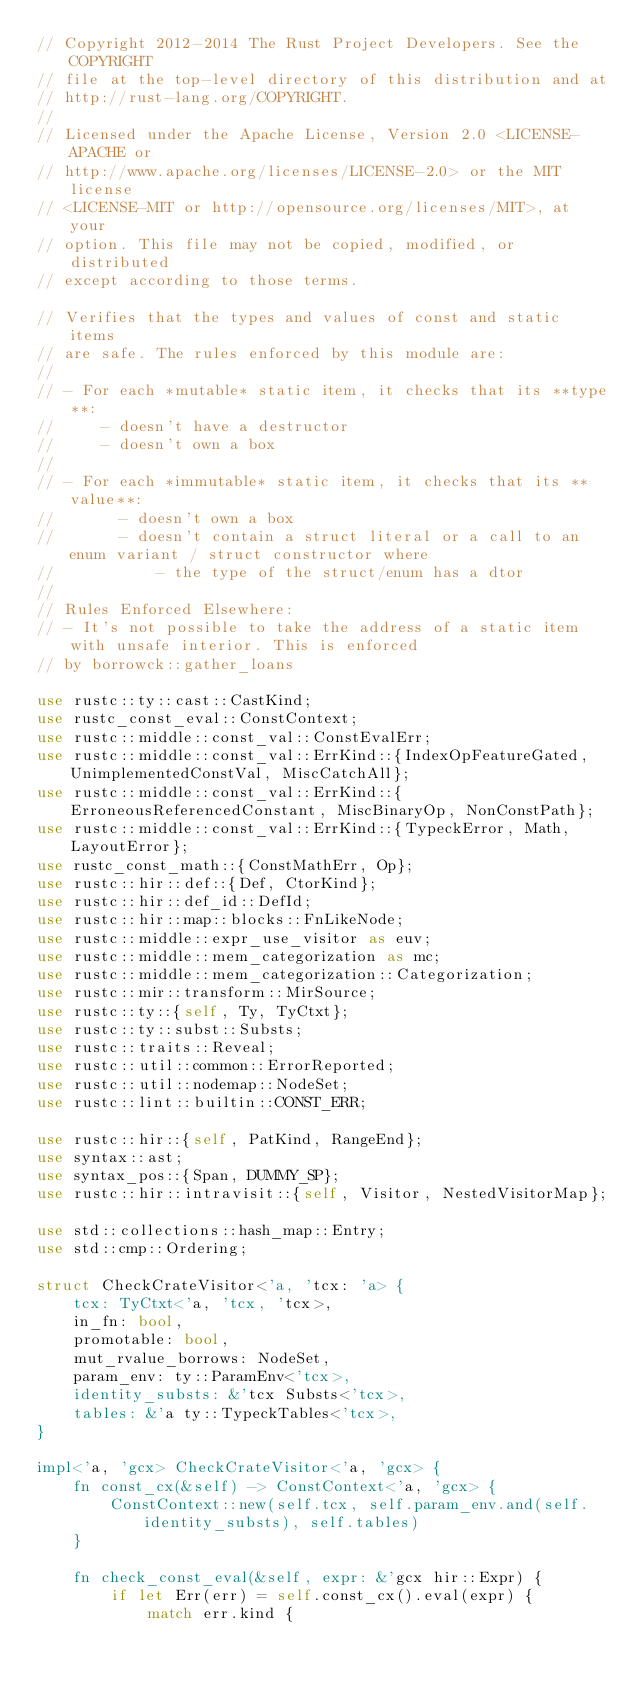Convert code to text. <code><loc_0><loc_0><loc_500><loc_500><_Rust_>// Copyright 2012-2014 The Rust Project Developers. See the COPYRIGHT
// file at the top-level directory of this distribution and at
// http://rust-lang.org/COPYRIGHT.
//
// Licensed under the Apache License, Version 2.0 <LICENSE-APACHE or
// http://www.apache.org/licenses/LICENSE-2.0> or the MIT license
// <LICENSE-MIT or http://opensource.org/licenses/MIT>, at your
// option. This file may not be copied, modified, or distributed
// except according to those terms.

// Verifies that the types and values of const and static items
// are safe. The rules enforced by this module are:
//
// - For each *mutable* static item, it checks that its **type**:
//     - doesn't have a destructor
//     - doesn't own a box
//
// - For each *immutable* static item, it checks that its **value**:
//       - doesn't own a box
//       - doesn't contain a struct literal or a call to an enum variant / struct constructor where
//           - the type of the struct/enum has a dtor
//
// Rules Enforced Elsewhere:
// - It's not possible to take the address of a static item with unsafe interior. This is enforced
// by borrowck::gather_loans

use rustc::ty::cast::CastKind;
use rustc_const_eval::ConstContext;
use rustc::middle::const_val::ConstEvalErr;
use rustc::middle::const_val::ErrKind::{IndexOpFeatureGated, UnimplementedConstVal, MiscCatchAll};
use rustc::middle::const_val::ErrKind::{ErroneousReferencedConstant, MiscBinaryOp, NonConstPath};
use rustc::middle::const_val::ErrKind::{TypeckError, Math, LayoutError};
use rustc_const_math::{ConstMathErr, Op};
use rustc::hir::def::{Def, CtorKind};
use rustc::hir::def_id::DefId;
use rustc::hir::map::blocks::FnLikeNode;
use rustc::middle::expr_use_visitor as euv;
use rustc::middle::mem_categorization as mc;
use rustc::middle::mem_categorization::Categorization;
use rustc::mir::transform::MirSource;
use rustc::ty::{self, Ty, TyCtxt};
use rustc::ty::subst::Substs;
use rustc::traits::Reveal;
use rustc::util::common::ErrorReported;
use rustc::util::nodemap::NodeSet;
use rustc::lint::builtin::CONST_ERR;

use rustc::hir::{self, PatKind, RangeEnd};
use syntax::ast;
use syntax_pos::{Span, DUMMY_SP};
use rustc::hir::intravisit::{self, Visitor, NestedVisitorMap};

use std::collections::hash_map::Entry;
use std::cmp::Ordering;

struct CheckCrateVisitor<'a, 'tcx: 'a> {
    tcx: TyCtxt<'a, 'tcx, 'tcx>,
    in_fn: bool,
    promotable: bool,
    mut_rvalue_borrows: NodeSet,
    param_env: ty::ParamEnv<'tcx>,
    identity_substs: &'tcx Substs<'tcx>,
    tables: &'a ty::TypeckTables<'tcx>,
}

impl<'a, 'gcx> CheckCrateVisitor<'a, 'gcx> {
    fn const_cx(&self) -> ConstContext<'a, 'gcx> {
        ConstContext::new(self.tcx, self.param_env.and(self.identity_substs), self.tables)
    }

    fn check_const_eval(&self, expr: &'gcx hir::Expr) {
        if let Err(err) = self.const_cx().eval(expr) {
            match err.kind {</code> 